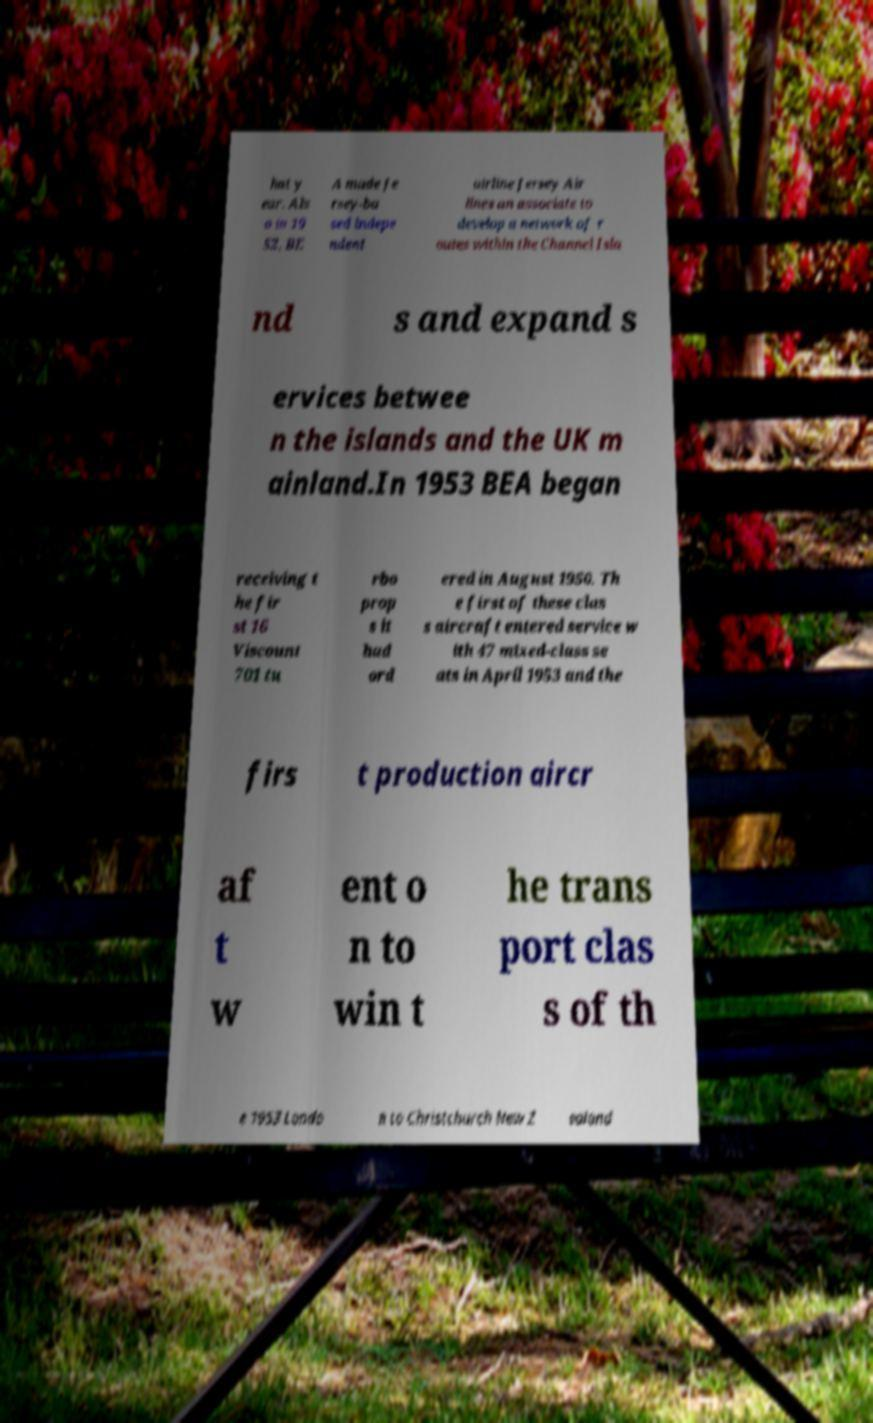Could you extract and type out the text from this image? hat y ear. Als o in 19 52, BE A made Je rsey-ba sed indepe ndent airline Jersey Air lines an associate to develop a network of r outes within the Channel Isla nd s and expand s ervices betwee n the islands and the UK m ainland.In 1953 BEA began receiving t he fir st 16 Viscount 701 tu rbo prop s it had ord ered in August 1950. Th e first of these clas s aircraft entered service w ith 47 mixed-class se ats in April 1953 and the firs t production aircr af t w ent o n to win t he trans port clas s of th e 1953 Londo n to Christchurch New Z ealand 